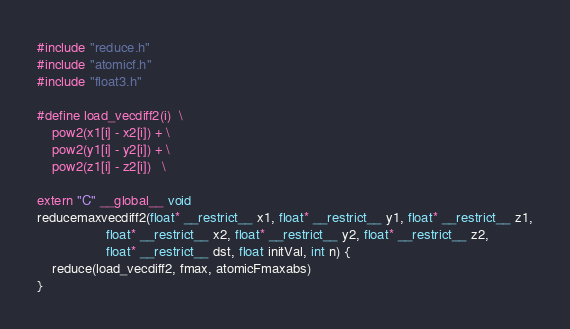<code> <loc_0><loc_0><loc_500><loc_500><_Cuda_>#include "reduce.h"
#include "atomicf.h"
#include "float3.h"

#define load_vecdiff2(i)  \
	pow2(x1[i] - x2[i]) + \
	pow2(y1[i] - y2[i]) + \
	pow2(z1[i] - z2[i])   \
 
extern "C" __global__ void
reducemaxvecdiff2(float* __restrict__ x1, float* __restrict__ y1, float* __restrict__ z1,
                  float* __restrict__ x2, float* __restrict__ y2, float* __restrict__ z2,
                  float* __restrict__ dst, float initVal, int n) {
	reduce(load_vecdiff2, fmax, atomicFmaxabs)
}

</code> 